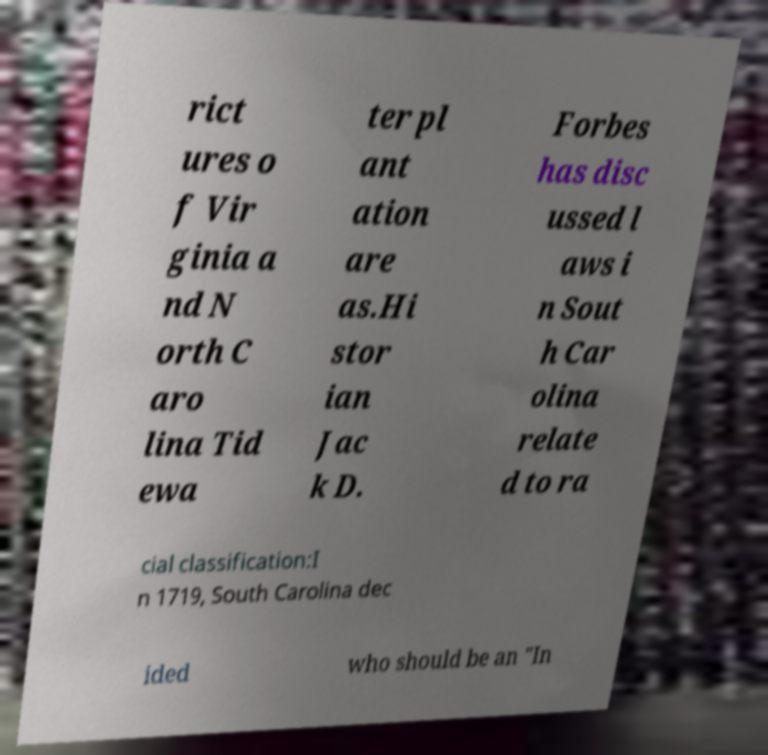Could you extract and type out the text from this image? rict ures o f Vir ginia a nd N orth C aro lina Tid ewa ter pl ant ation are as.Hi stor ian Jac k D. Forbes has disc ussed l aws i n Sout h Car olina relate d to ra cial classification:I n 1719, South Carolina dec ided who should be an "In 